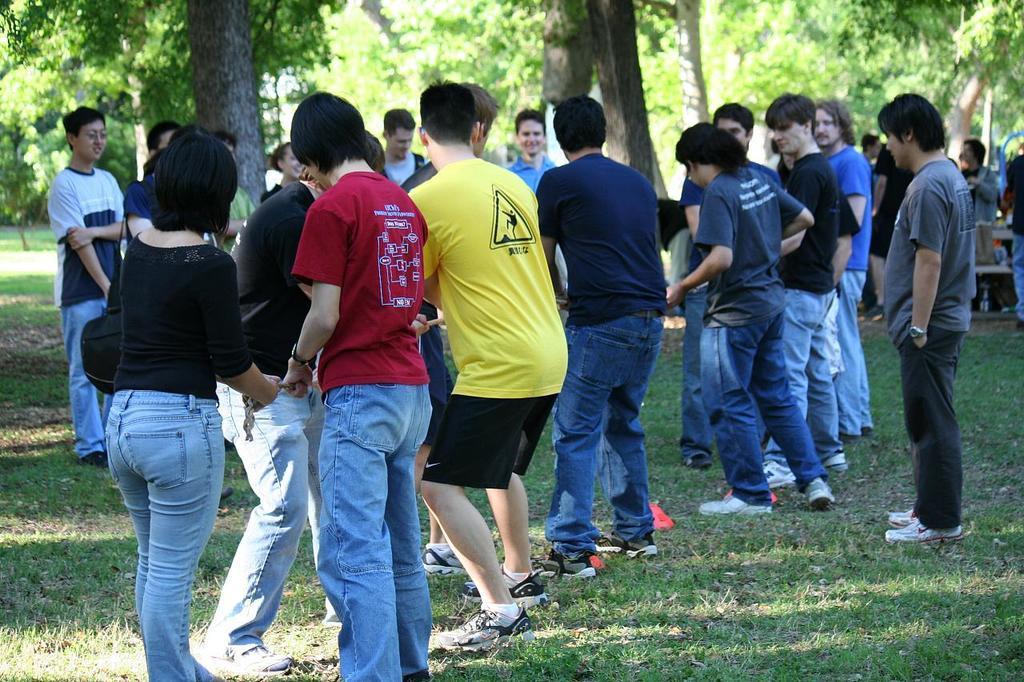In one or two sentences, can you explain what this image depicts? This is an outside view. At the bottom, I can see the grass on the ground. Here I can see a crowd of people wearing t-shirts, shoes and standing. In the background there are many trees. 